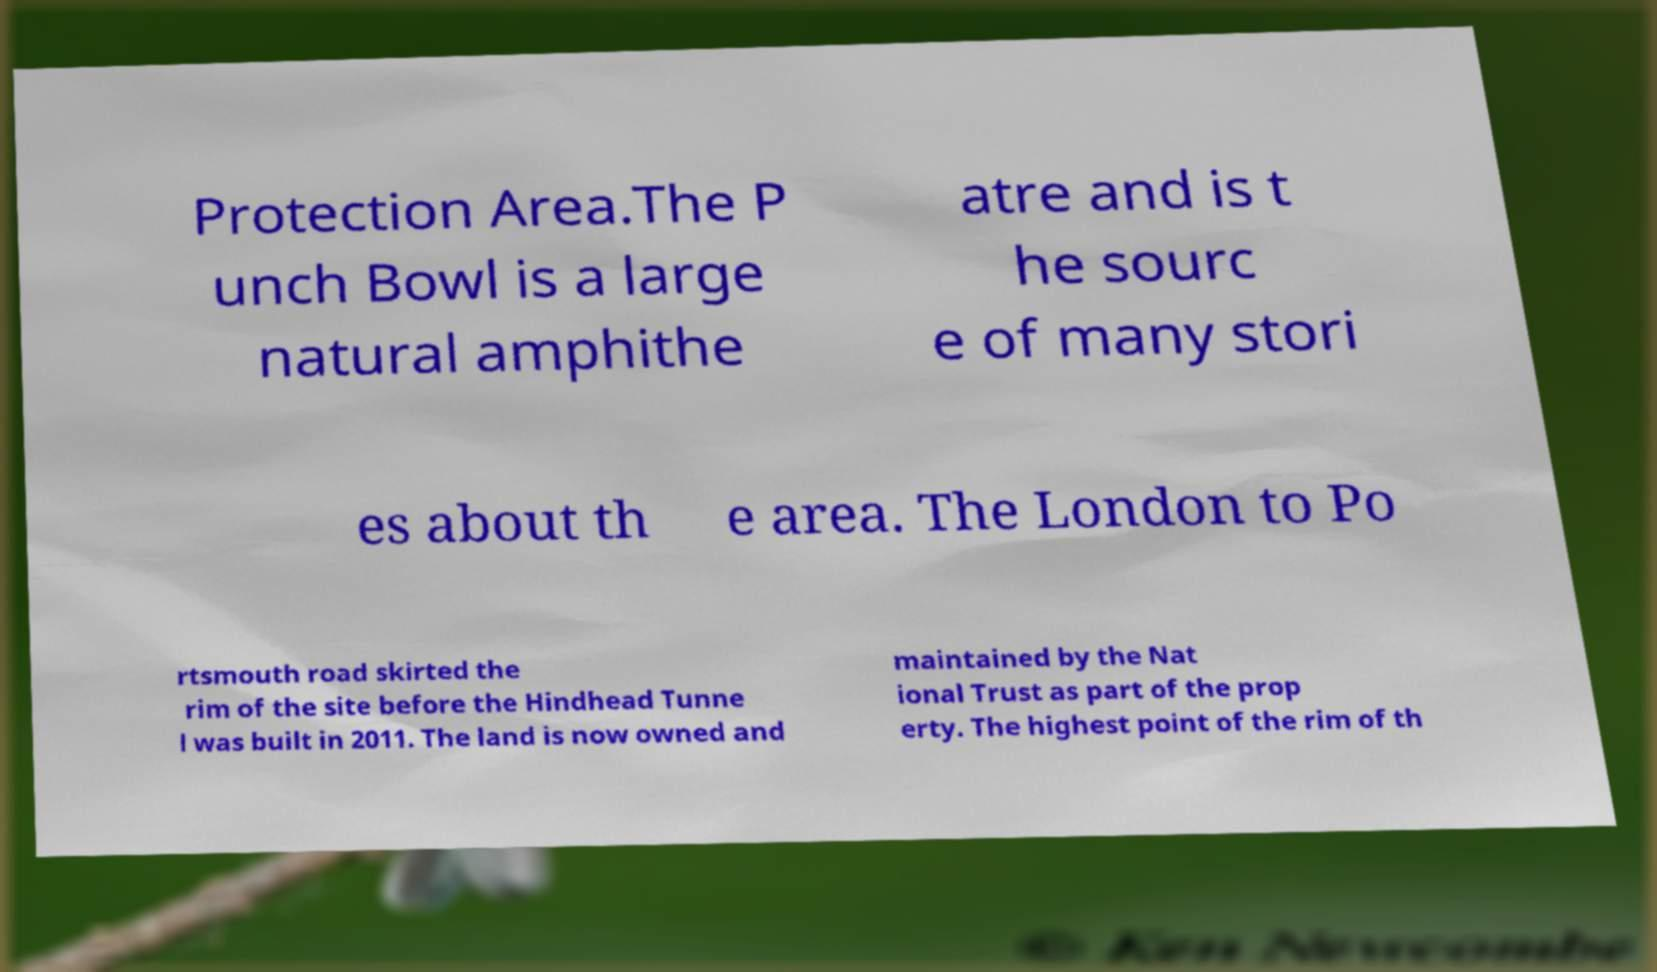There's text embedded in this image that I need extracted. Can you transcribe it verbatim? Protection Area.The P unch Bowl is a large natural amphithe atre and is t he sourc e of many stori es about th e area. The London to Po rtsmouth road skirted the rim of the site before the Hindhead Tunne l was built in 2011. The land is now owned and maintained by the Nat ional Trust as part of the prop erty. The highest point of the rim of th 